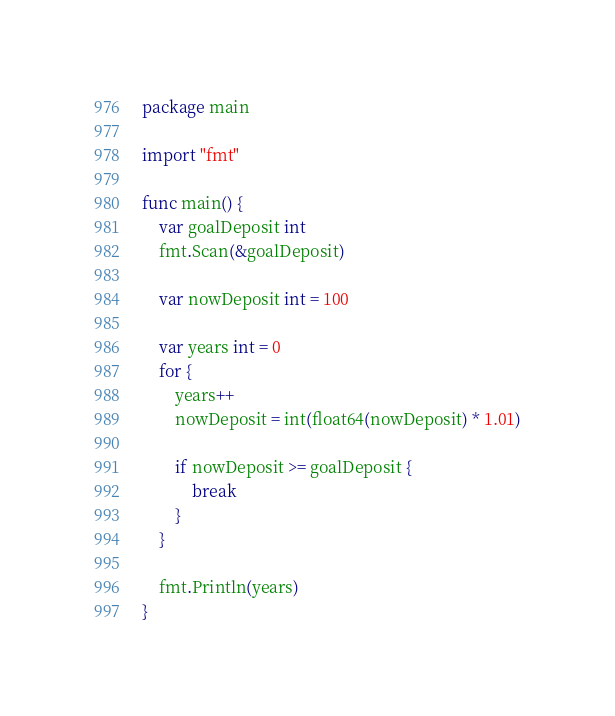Convert code to text. <code><loc_0><loc_0><loc_500><loc_500><_Go_>package main

import "fmt"

func main() {
	var goalDeposit int
	fmt.Scan(&goalDeposit)

	var nowDeposit int = 100

	var years int = 0
	for {
		years++
		nowDeposit = int(float64(nowDeposit) * 1.01)

		if nowDeposit >= goalDeposit {
			break
		}
	}

	fmt.Println(years)
}
</code> 